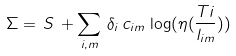Convert formula to latex. <formula><loc_0><loc_0><loc_500><loc_500>\Sigma = \, S \, + \sum _ { i , m } \, \delta _ { i } \, c _ { i m } \, \log ( \eta ( \frac { T i } { l _ { i m } } ) )</formula> 